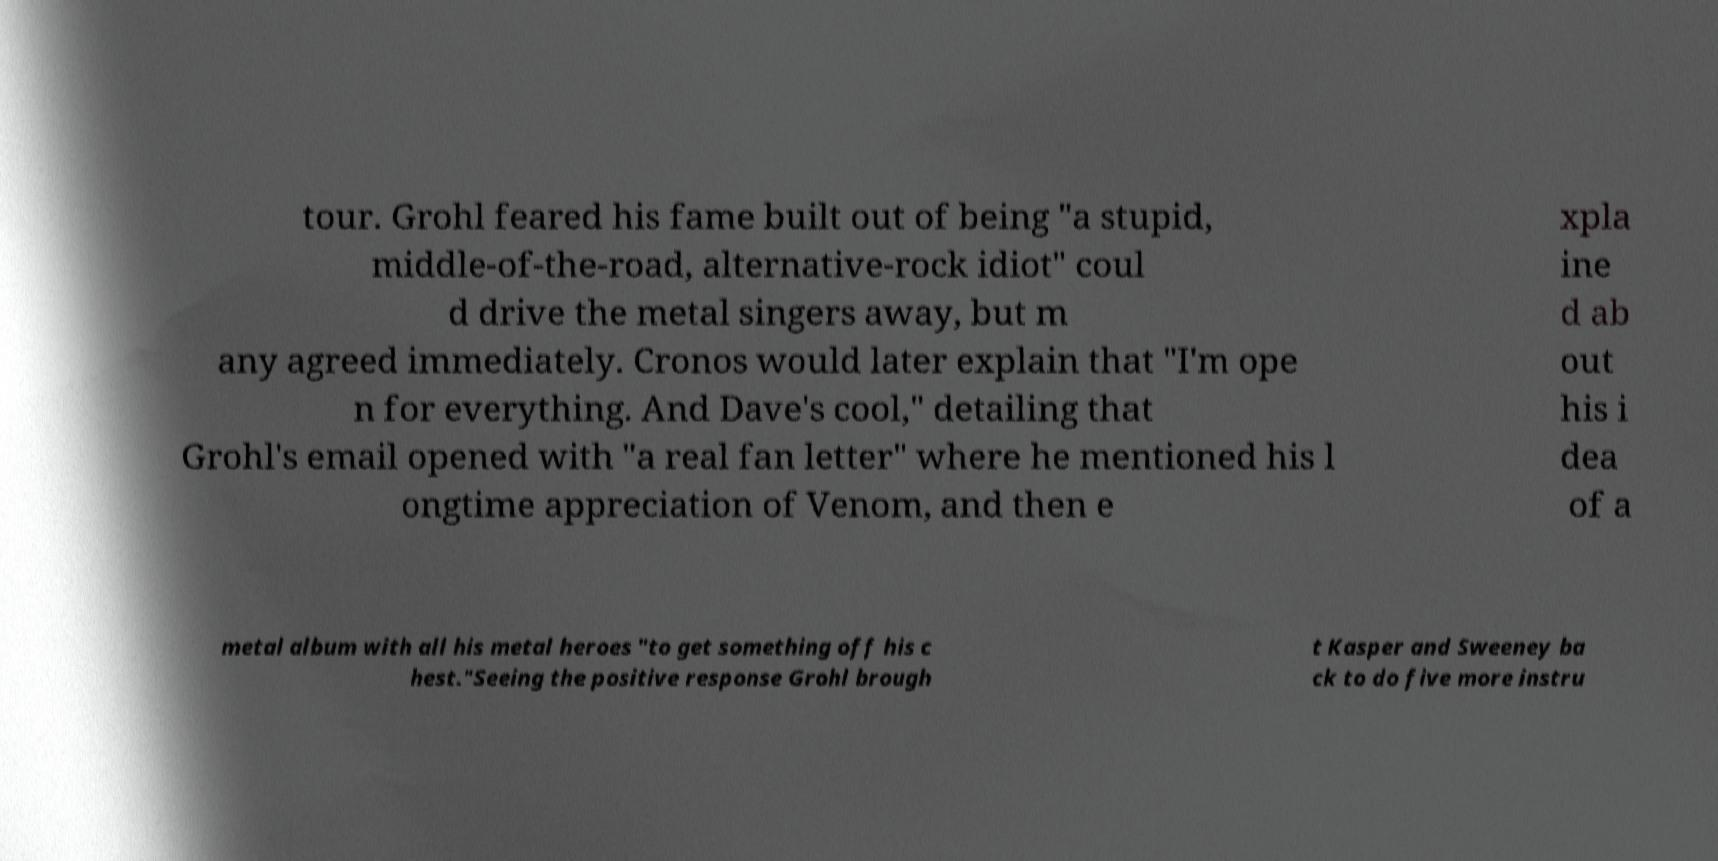Can you accurately transcribe the text from the provided image for me? tour. Grohl feared his fame built out of being "a stupid, middle-of-the-road, alternative-rock idiot" coul d drive the metal singers away, but m any agreed immediately. Cronos would later explain that "I'm ope n for everything. And Dave's cool," detailing that Grohl's email opened with "a real fan letter" where he mentioned his l ongtime appreciation of Venom, and then e xpla ine d ab out his i dea of a metal album with all his metal heroes "to get something off his c hest."Seeing the positive response Grohl brough t Kasper and Sweeney ba ck to do five more instru 